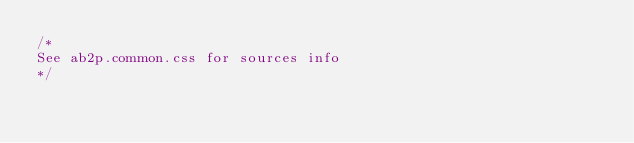<code> <loc_0><loc_0><loc_500><loc_500><_CSS_>/*
See ab2p.common.css for sources info
*/</code> 